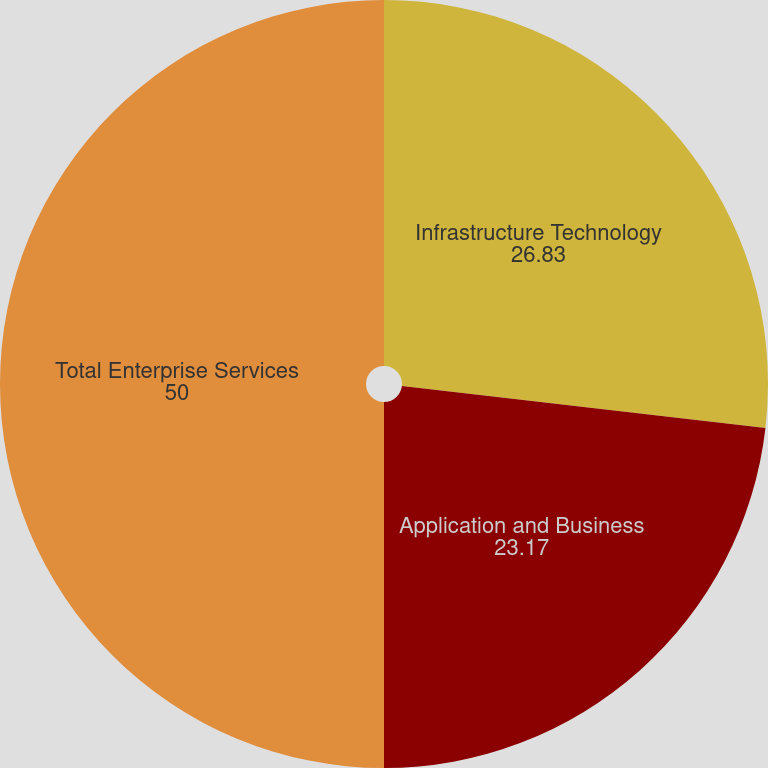Convert chart to OTSL. <chart><loc_0><loc_0><loc_500><loc_500><pie_chart><fcel>Infrastructure Technology<fcel>Application and Business<fcel>Total Enterprise Services<nl><fcel>26.83%<fcel>23.17%<fcel>50.0%<nl></chart> 